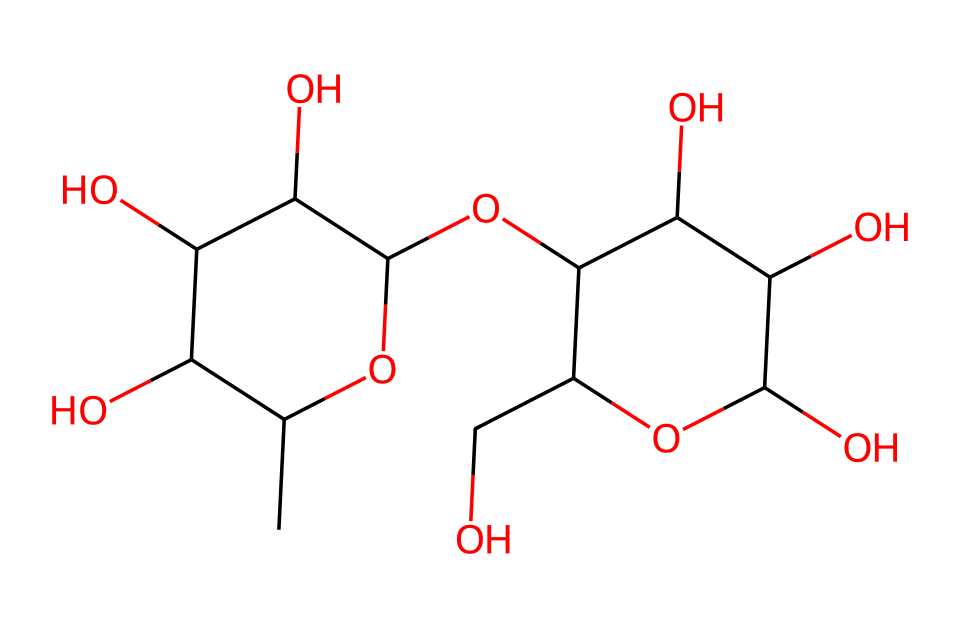how many carbon atoms are in this chemical? Counting the "C" in the SMILES, there are 12 carbon atoms in total in the structure provided.
Answer: 12 what type of fluid is represented by this chemical? The chemical's structure does not show typical properties of Newtonian fluids; it demonstrates characteristics of thixotropic fluids, which become less viscous under shear stress.
Answer: thixotropic how many hydroxyl (OH) groups are present in this molecule? By analyzing the structure, there are 6 hydroxyl (OH) groups present in the chemical. Each hydroxyl group contributes to the thixotropic and hydrophilic properties of this fluid.
Answer: 6 what effect do the hydroxyl groups have on the chemical? The presence of multiple hydroxyl groups indicates high polarity, leading to increased interaction with water and enhancing its thixotropic properties, which allow it to flow under force.
Answer: increase viscosity how many rings are present in the structure? The SMILES indicates two cyclic structures; hence, there are 2 rings in the chemical's structure. Rings contribute to the overall stability and functional interactions of the molecule.
Answer: 2 what is the significance of the thixotropic property in eco-friendly packaging solutions? Thixotropic properties allow the material to be malleable under stress, which is beneficial for shaping and molding packaging materials while maintaining strength when at rest, thus supporting sustainability.
Answer: flexibility 